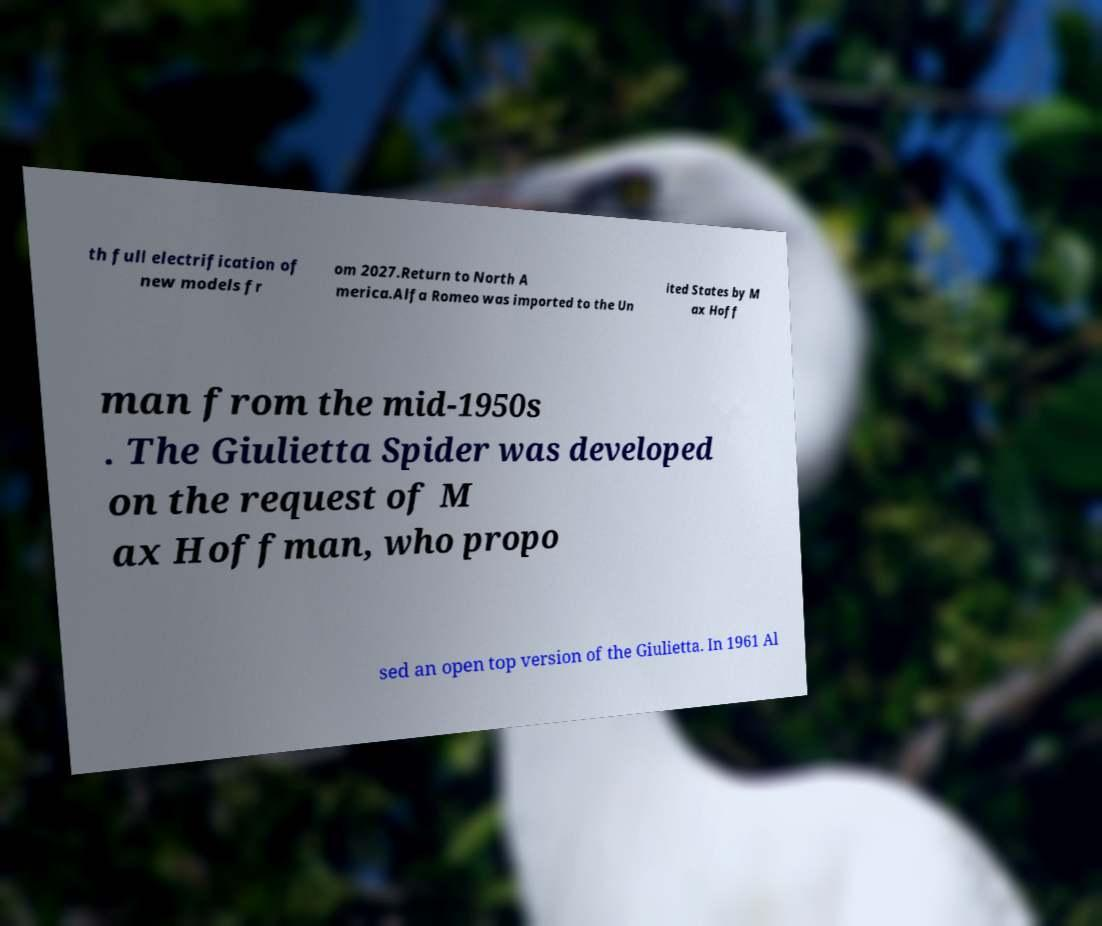Could you assist in decoding the text presented in this image and type it out clearly? th full electrification of new models fr om 2027.Return to North A merica.Alfa Romeo was imported to the Un ited States by M ax Hoff man from the mid-1950s . The Giulietta Spider was developed on the request of M ax Hoffman, who propo sed an open top version of the Giulietta. In 1961 Al 